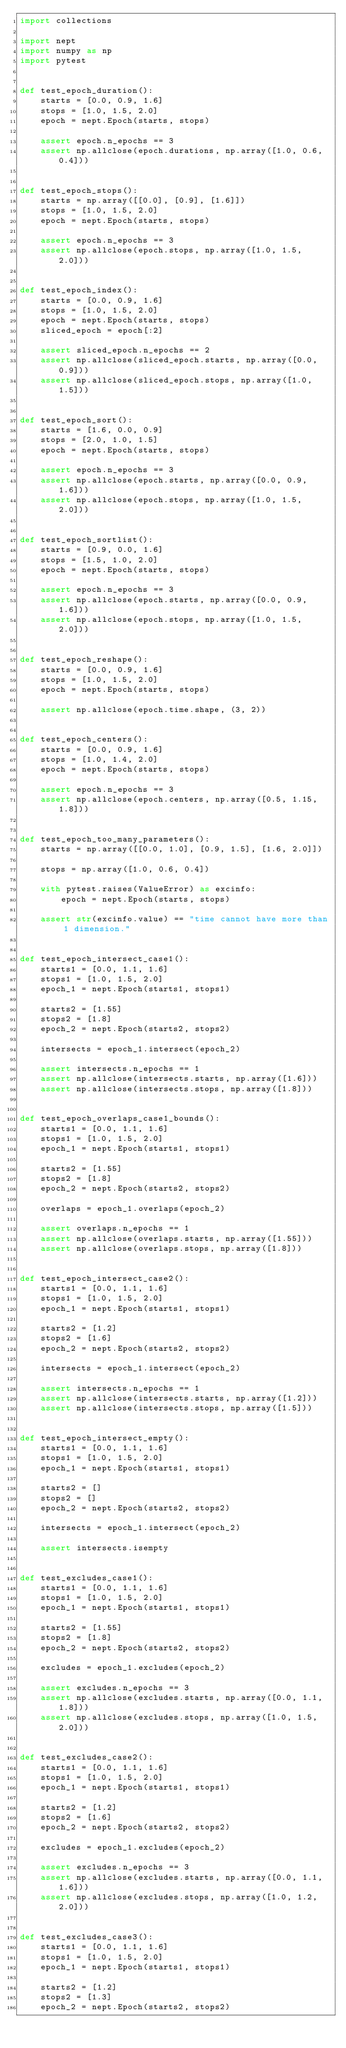Convert code to text. <code><loc_0><loc_0><loc_500><loc_500><_Python_>import collections

import nept
import numpy as np
import pytest


def test_epoch_duration():
    starts = [0.0, 0.9, 1.6]
    stops = [1.0, 1.5, 2.0]
    epoch = nept.Epoch(starts, stops)

    assert epoch.n_epochs == 3
    assert np.allclose(epoch.durations, np.array([1.0, 0.6, 0.4]))


def test_epoch_stops():
    starts = np.array([[0.0], [0.9], [1.6]])
    stops = [1.0, 1.5, 2.0]
    epoch = nept.Epoch(starts, stops)

    assert epoch.n_epochs == 3
    assert np.allclose(epoch.stops, np.array([1.0, 1.5, 2.0]))


def test_epoch_index():
    starts = [0.0, 0.9, 1.6]
    stops = [1.0, 1.5, 2.0]
    epoch = nept.Epoch(starts, stops)
    sliced_epoch = epoch[:2]

    assert sliced_epoch.n_epochs == 2
    assert np.allclose(sliced_epoch.starts, np.array([0.0, 0.9]))
    assert np.allclose(sliced_epoch.stops, np.array([1.0, 1.5]))


def test_epoch_sort():
    starts = [1.6, 0.0, 0.9]
    stops = [2.0, 1.0, 1.5]
    epoch = nept.Epoch(starts, stops)

    assert epoch.n_epochs == 3
    assert np.allclose(epoch.starts, np.array([0.0, 0.9, 1.6]))
    assert np.allclose(epoch.stops, np.array([1.0, 1.5, 2.0]))


def test_epoch_sortlist():
    starts = [0.9, 0.0, 1.6]
    stops = [1.5, 1.0, 2.0]
    epoch = nept.Epoch(starts, stops)

    assert epoch.n_epochs == 3
    assert np.allclose(epoch.starts, np.array([0.0, 0.9, 1.6]))
    assert np.allclose(epoch.stops, np.array([1.0, 1.5, 2.0]))


def test_epoch_reshape():
    starts = [0.0, 0.9, 1.6]
    stops = [1.0, 1.5, 2.0]
    epoch = nept.Epoch(starts, stops)

    assert np.allclose(epoch.time.shape, (3, 2))


def test_epoch_centers():
    starts = [0.0, 0.9, 1.6]
    stops = [1.0, 1.4, 2.0]
    epoch = nept.Epoch(starts, stops)

    assert epoch.n_epochs == 3
    assert np.allclose(epoch.centers, np.array([0.5, 1.15, 1.8]))


def test_epoch_too_many_parameters():
    starts = np.array([[0.0, 1.0], [0.9, 1.5], [1.6, 2.0]])

    stops = np.array([1.0, 0.6, 0.4])

    with pytest.raises(ValueError) as excinfo:
        epoch = nept.Epoch(starts, stops)

    assert str(excinfo.value) == "time cannot have more than 1 dimension."


def test_epoch_intersect_case1():
    starts1 = [0.0, 1.1, 1.6]
    stops1 = [1.0, 1.5, 2.0]
    epoch_1 = nept.Epoch(starts1, stops1)

    starts2 = [1.55]
    stops2 = [1.8]
    epoch_2 = nept.Epoch(starts2, stops2)

    intersects = epoch_1.intersect(epoch_2)

    assert intersects.n_epochs == 1
    assert np.allclose(intersects.starts, np.array([1.6]))
    assert np.allclose(intersects.stops, np.array([1.8]))


def test_epoch_overlaps_case1_bounds():
    starts1 = [0.0, 1.1, 1.6]
    stops1 = [1.0, 1.5, 2.0]
    epoch_1 = nept.Epoch(starts1, stops1)

    starts2 = [1.55]
    stops2 = [1.8]
    epoch_2 = nept.Epoch(starts2, stops2)

    overlaps = epoch_1.overlaps(epoch_2)

    assert overlaps.n_epochs == 1
    assert np.allclose(overlaps.starts, np.array([1.55]))
    assert np.allclose(overlaps.stops, np.array([1.8]))


def test_epoch_intersect_case2():
    starts1 = [0.0, 1.1, 1.6]
    stops1 = [1.0, 1.5, 2.0]
    epoch_1 = nept.Epoch(starts1, stops1)

    starts2 = [1.2]
    stops2 = [1.6]
    epoch_2 = nept.Epoch(starts2, stops2)

    intersects = epoch_1.intersect(epoch_2)

    assert intersects.n_epochs == 1
    assert np.allclose(intersects.starts, np.array([1.2]))
    assert np.allclose(intersects.stops, np.array([1.5]))


def test_epoch_intersect_empty():
    starts1 = [0.0, 1.1, 1.6]
    stops1 = [1.0, 1.5, 2.0]
    epoch_1 = nept.Epoch(starts1, stops1)

    starts2 = []
    stops2 = []
    epoch_2 = nept.Epoch(starts2, stops2)

    intersects = epoch_1.intersect(epoch_2)

    assert intersects.isempty


def test_excludes_case1():
    starts1 = [0.0, 1.1, 1.6]
    stops1 = [1.0, 1.5, 2.0]
    epoch_1 = nept.Epoch(starts1, stops1)

    starts2 = [1.55]
    stops2 = [1.8]
    epoch_2 = nept.Epoch(starts2, stops2)

    excludes = epoch_1.excludes(epoch_2)

    assert excludes.n_epochs == 3
    assert np.allclose(excludes.starts, np.array([0.0, 1.1, 1.8]))
    assert np.allclose(excludes.stops, np.array([1.0, 1.5, 2.0]))


def test_excludes_case2():
    starts1 = [0.0, 1.1, 1.6]
    stops1 = [1.0, 1.5, 2.0]
    epoch_1 = nept.Epoch(starts1, stops1)

    starts2 = [1.2]
    stops2 = [1.6]
    epoch_2 = nept.Epoch(starts2, stops2)

    excludes = epoch_1.excludes(epoch_2)

    assert excludes.n_epochs == 3
    assert np.allclose(excludes.starts, np.array([0.0, 1.1, 1.6]))
    assert np.allclose(excludes.stops, np.array([1.0, 1.2, 2.0]))


def test_excludes_case3():
    starts1 = [0.0, 1.1, 1.6]
    stops1 = [1.0, 1.5, 2.0]
    epoch_1 = nept.Epoch(starts1, stops1)

    starts2 = [1.2]
    stops2 = [1.3]
    epoch_2 = nept.Epoch(starts2, stops2)
</code> 